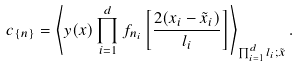<formula> <loc_0><loc_0><loc_500><loc_500>c _ { \{ n \} } = \left \langle y ( { x } ) \prod _ { i = 1 } ^ { d } f _ { n _ { i } } \left [ \frac { 2 ( x _ { i } - \tilde { x } _ { i } ) } { l _ { i } } \right ] \right \rangle _ { \prod _ { i = 1 } ^ { d } l _ { i } ; \tilde { x } } .</formula> 